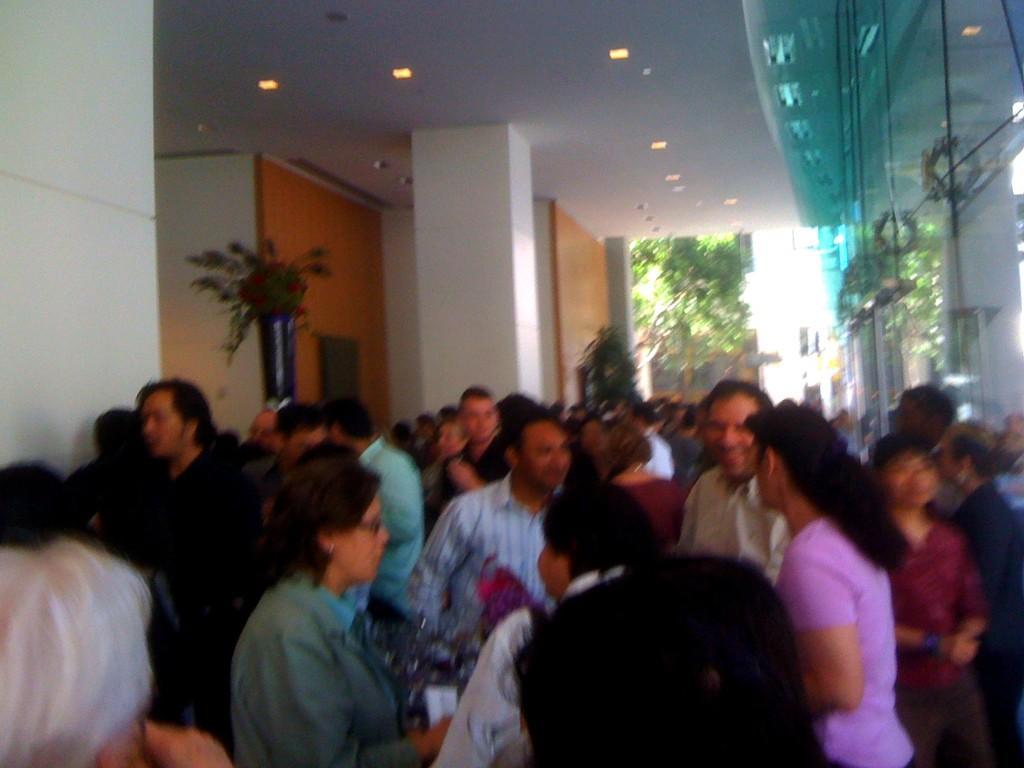How would you summarize this image in a sentence or two? There are many people. On the ceiling there are lights. On the right side there is a glass wall. On the left side there is a flower bouquet, pillar and wall. In the background it is blurred. 